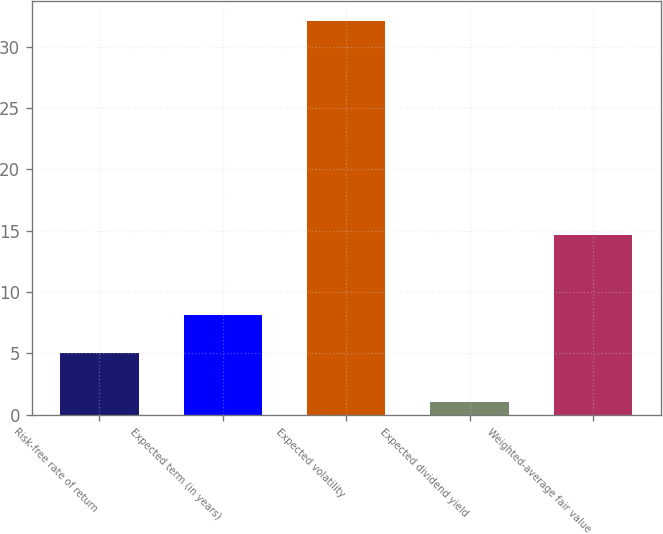Convert chart to OTSL. <chart><loc_0><loc_0><loc_500><loc_500><bar_chart><fcel>Risk-free rate of return<fcel>Expected term (in years)<fcel>Expected volatility<fcel>Expected dividend yield<fcel>Weighted-average fair value<nl><fcel>5<fcel>8.11<fcel>32.1<fcel>1<fcel>14.64<nl></chart> 